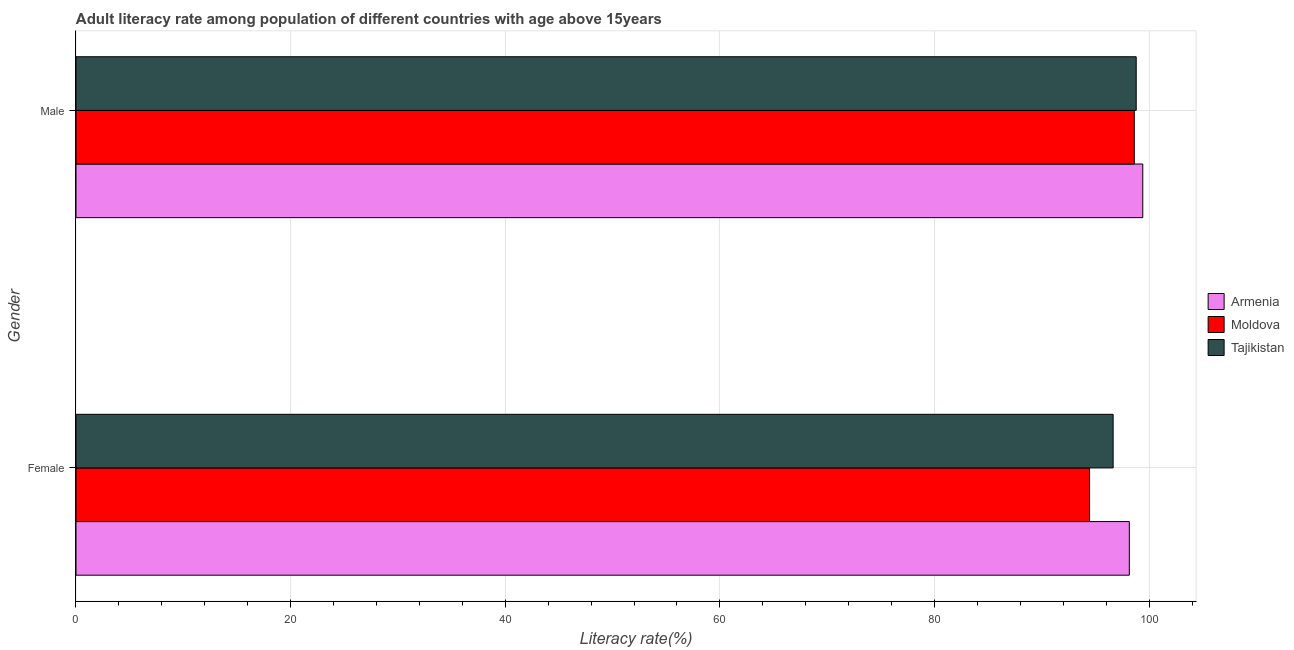How many different coloured bars are there?
Provide a succinct answer. 3. Are the number of bars on each tick of the Y-axis equal?
Make the answer very short. Yes. How many bars are there on the 2nd tick from the bottom?
Offer a terse response. 3. What is the female adult literacy rate in Tajikistan?
Provide a succinct answer. 96.64. Across all countries, what is the maximum male adult literacy rate?
Provide a succinct answer. 99.4. Across all countries, what is the minimum male adult literacy rate?
Provide a succinct answer. 98.61. In which country was the male adult literacy rate maximum?
Offer a very short reply. Armenia. In which country was the female adult literacy rate minimum?
Offer a terse response. Moldova. What is the total female adult literacy rate in the graph?
Give a very brief answer. 289.24. What is the difference between the female adult literacy rate in Tajikistan and that in Moldova?
Your answer should be compact. 2.2. What is the difference between the female adult literacy rate in Tajikistan and the male adult literacy rate in Moldova?
Offer a terse response. -1.97. What is the average female adult literacy rate per country?
Keep it short and to the point. 96.41. What is the difference between the male adult literacy rate and female adult literacy rate in Armenia?
Your answer should be compact. 1.25. What is the ratio of the male adult literacy rate in Moldova to that in Tajikistan?
Offer a terse response. 1. In how many countries, is the female adult literacy rate greater than the average female adult literacy rate taken over all countries?
Keep it short and to the point. 2. What does the 1st bar from the top in Female represents?
Offer a very short reply. Tajikistan. What does the 1st bar from the bottom in Male represents?
Ensure brevity in your answer.  Armenia. How many bars are there?
Your response must be concise. 6. Are all the bars in the graph horizontal?
Offer a terse response. Yes. How many countries are there in the graph?
Your answer should be compact. 3. Are the values on the major ticks of X-axis written in scientific E-notation?
Give a very brief answer. No. Does the graph contain grids?
Your answer should be compact. Yes. Where does the legend appear in the graph?
Offer a terse response. Center right. How are the legend labels stacked?
Make the answer very short. Vertical. What is the title of the graph?
Offer a very short reply. Adult literacy rate among population of different countries with age above 15years. What is the label or title of the X-axis?
Keep it short and to the point. Literacy rate(%). What is the label or title of the Y-axis?
Your answer should be compact. Gender. What is the Literacy rate(%) of Armenia in Female?
Your answer should be very brief. 98.15. What is the Literacy rate(%) in Moldova in Female?
Ensure brevity in your answer.  94.44. What is the Literacy rate(%) of Tajikistan in Female?
Your answer should be very brief. 96.64. What is the Literacy rate(%) of Armenia in Male?
Ensure brevity in your answer.  99.4. What is the Literacy rate(%) in Moldova in Male?
Your answer should be very brief. 98.61. What is the Literacy rate(%) in Tajikistan in Male?
Keep it short and to the point. 98.79. Across all Gender, what is the maximum Literacy rate(%) of Armenia?
Your answer should be very brief. 99.4. Across all Gender, what is the maximum Literacy rate(%) in Moldova?
Your answer should be very brief. 98.61. Across all Gender, what is the maximum Literacy rate(%) in Tajikistan?
Keep it short and to the point. 98.79. Across all Gender, what is the minimum Literacy rate(%) of Armenia?
Your response must be concise. 98.15. Across all Gender, what is the minimum Literacy rate(%) in Moldova?
Your answer should be compact. 94.44. Across all Gender, what is the minimum Literacy rate(%) in Tajikistan?
Offer a terse response. 96.64. What is the total Literacy rate(%) of Armenia in the graph?
Your answer should be very brief. 197.55. What is the total Literacy rate(%) in Moldova in the graph?
Offer a terse response. 193.06. What is the total Literacy rate(%) in Tajikistan in the graph?
Your answer should be very brief. 195.43. What is the difference between the Literacy rate(%) of Armenia in Female and that in Male?
Provide a succinct answer. -1.25. What is the difference between the Literacy rate(%) of Moldova in Female and that in Male?
Keep it short and to the point. -4.17. What is the difference between the Literacy rate(%) in Tajikistan in Female and that in Male?
Make the answer very short. -2.15. What is the difference between the Literacy rate(%) of Armenia in Female and the Literacy rate(%) of Moldova in Male?
Make the answer very short. -0.46. What is the difference between the Literacy rate(%) in Armenia in Female and the Literacy rate(%) in Tajikistan in Male?
Provide a short and direct response. -0.64. What is the difference between the Literacy rate(%) of Moldova in Female and the Literacy rate(%) of Tajikistan in Male?
Keep it short and to the point. -4.35. What is the average Literacy rate(%) of Armenia per Gender?
Provide a succinct answer. 98.78. What is the average Literacy rate(%) in Moldova per Gender?
Provide a short and direct response. 96.53. What is the average Literacy rate(%) of Tajikistan per Gender?
Your answer should be compact. 97.72. What is the difference between the Literacy rate(%) in Armenia and Literacy rate(%) in Moldova in Female?
Make the answer very short. 3.71. What is the difference between the Literacy rate(%) in Armenia and Literacy rate(%) in Tajikistan in Female?
Provide a short and direct response. 1.51. What is the difference between the Literacy rate(%) of Moldova and Literacy rate(%) of Tajikistan in Female?
Your answer should be compact. -2.2. What is the difference between the Literacy rate(%) of Armenia and Literacy rate(%) of Moldova in Male?
Your answer should be very brief. 0.79. What is the difference between the Literacy rate(%) in Armenia and Literacy rate(%) in Tajikistan in Male?
Your response must be concise. 0.61. What is the difference between the Literacy rate(%) in Moldova and Literacy rate(%) in Tajikistan in Male?
Ensure brevity in your answer.  -0.18. What is the ratio of the Literacy rate(%) of Armenia in Female to that in Male?
Make the answer very short. 0.99. What is the ratio of the Literacy rate(%) in Moldova in Female to that in Male?
Ensure brevity in your answer.  0.96. What is the ratio of the Literacy rate(%) in Tajikistan in Female to that in Male?
Offer a very short reply. 0.98. What is the difference between the highest and the second highest Literacy rate(%) of Armenia?
Ensure brevity in your answer.  1.25. What is the difference between the highest and the second highest Literacy rate(%) in Moldova?
Your answer should be compact. 4.17. What is the difference between the highest and the second highest Literacy rate(%) in Tajikistan?
Keep it short and to the point. 2.15. What is the difference between the highest and the lowest Literacy rate(%) in Armenia?
Ensure brevity in your answer.  1.25. What is the difference between the highest and the lowest Literacy rate(%) of Moldova?
Offer a terse response. 4.17. What is the difference between the highest and the lowest Literacy rate(%) in Tajikistan?
Provide a succinct answer. 2.15. 